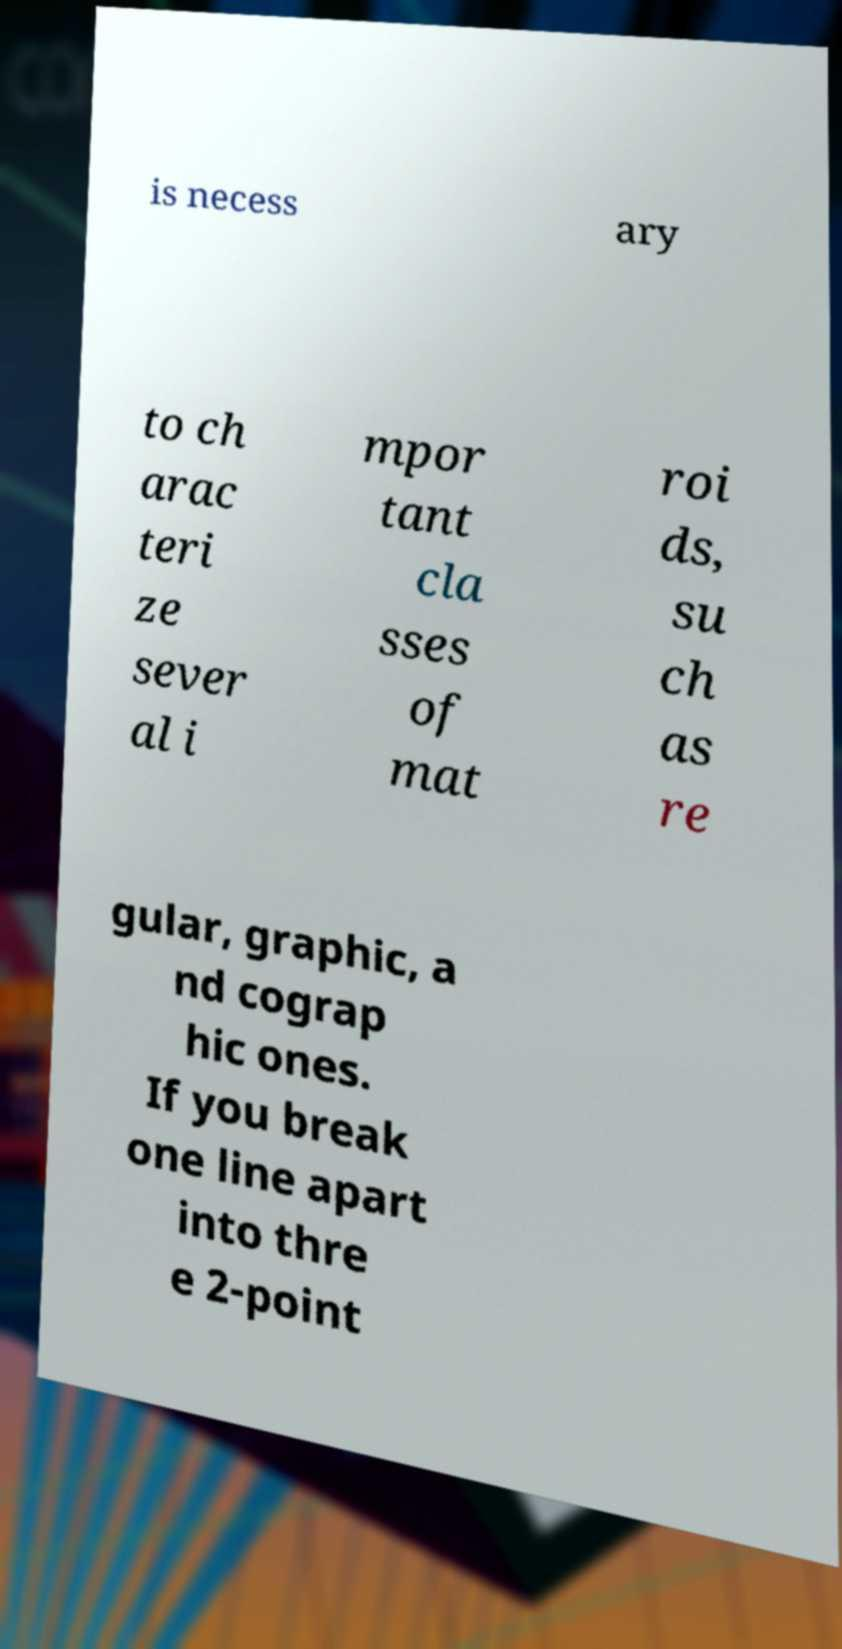Please read and relay the text visible in this image. What does it say? is necess ary to ch arac teri ze sever al i mpor tant cla sses of mat roi ds, su ch as re gular, graphic, a nd cograp hic ones. If you break one line apart into thre e 2-point 